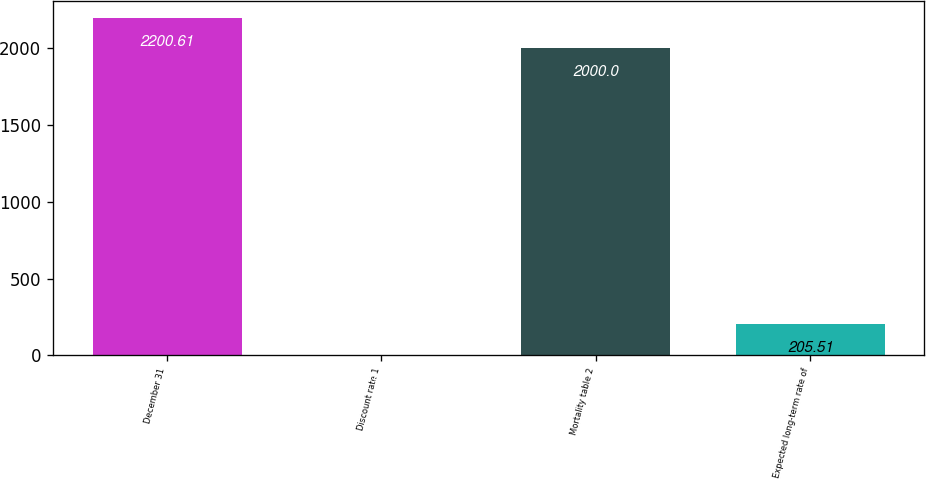Convert chart to OTSL. <chart><loc_0><loc_0><loc_500><loc_500><bar_chart><fcel>December 31<fcel>Discount rate 1<fcel>Mortality table 2<fcel>Expected long-term rate of<nl><fcel>2200.61<fcel>4.9<fcel>2000<fcel>205.51<nl></chart> 